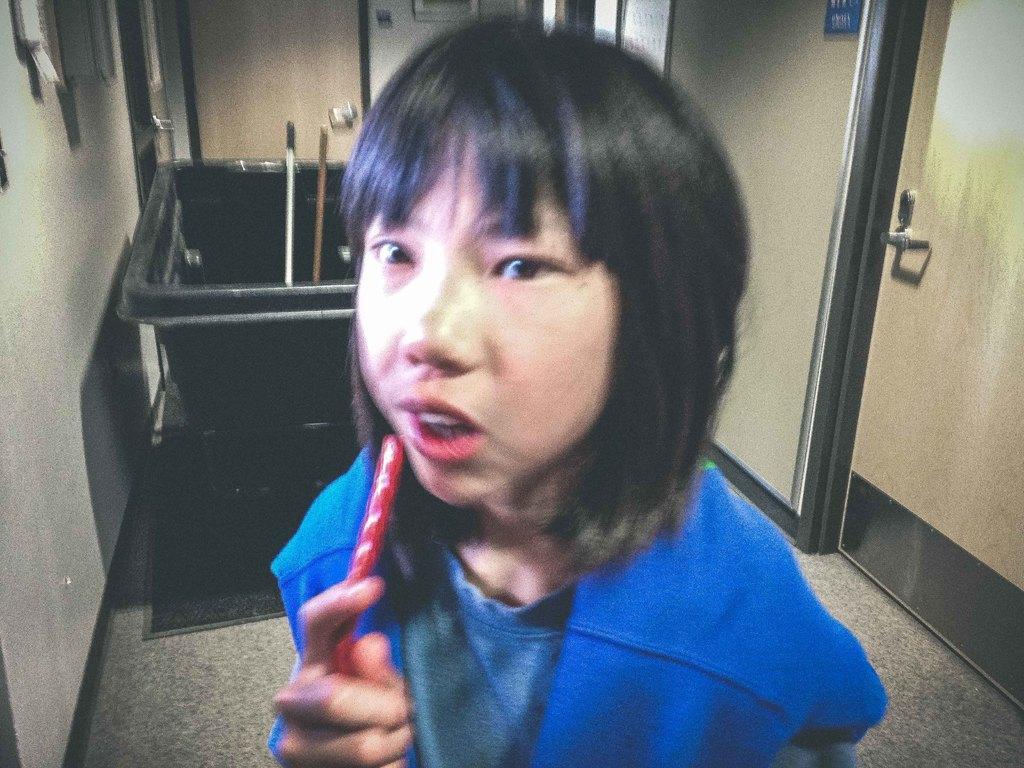Could you give a brief overview of what you see in this image? There is a girl in violet color t-shirt, holding an object and standing on the floor. In the background, there is a trolley. In the trolley, there are two sticks, there is door, wall and other objects. 